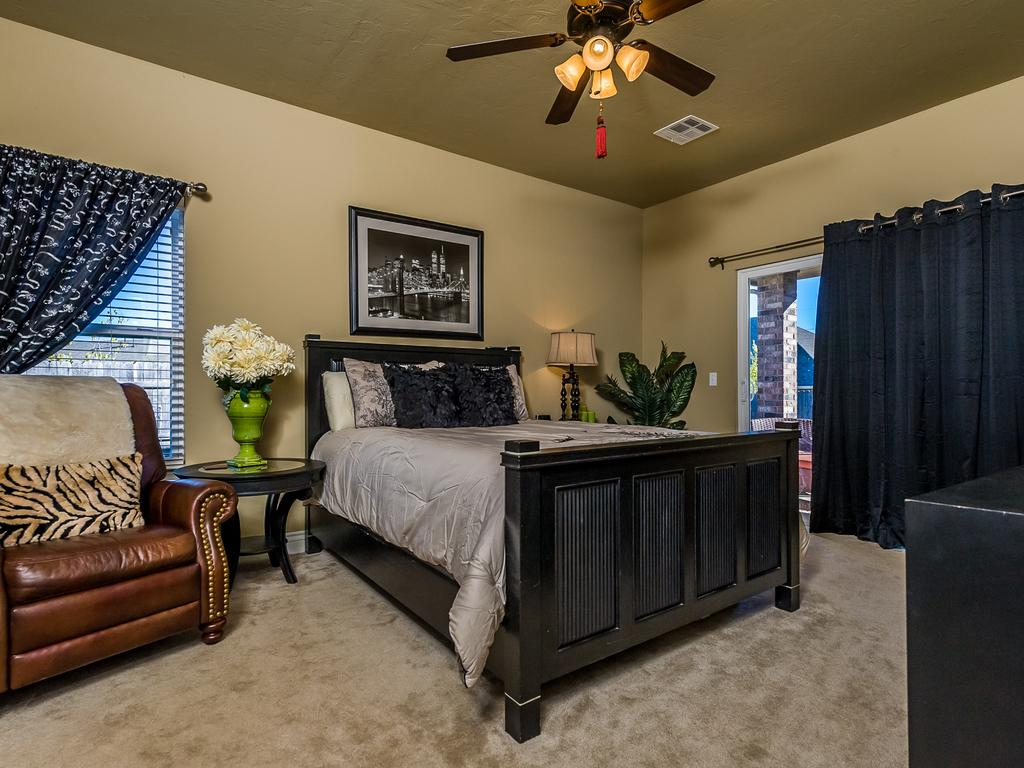What type of room is depicted in the image? The image shows an inner view of a bedroom. What is the main piece of furniture in the room? There is a bed in the room. What can be found on the bed? There are pillows on the bed. Are there any other furniture pieces in the room? Yes, there is a chair in the room. What type of window treatment is present in the room? There are curtains in the room. Is there any decoration on the walls? Yes, there is a photo frame on the wall. Are there any plants in the room? Yes, there is a plant in the room. What type of kite can be seen flying outside the window in the image? There is no kite visible in the image, as it is an inner view of a bedroom with no window view. 